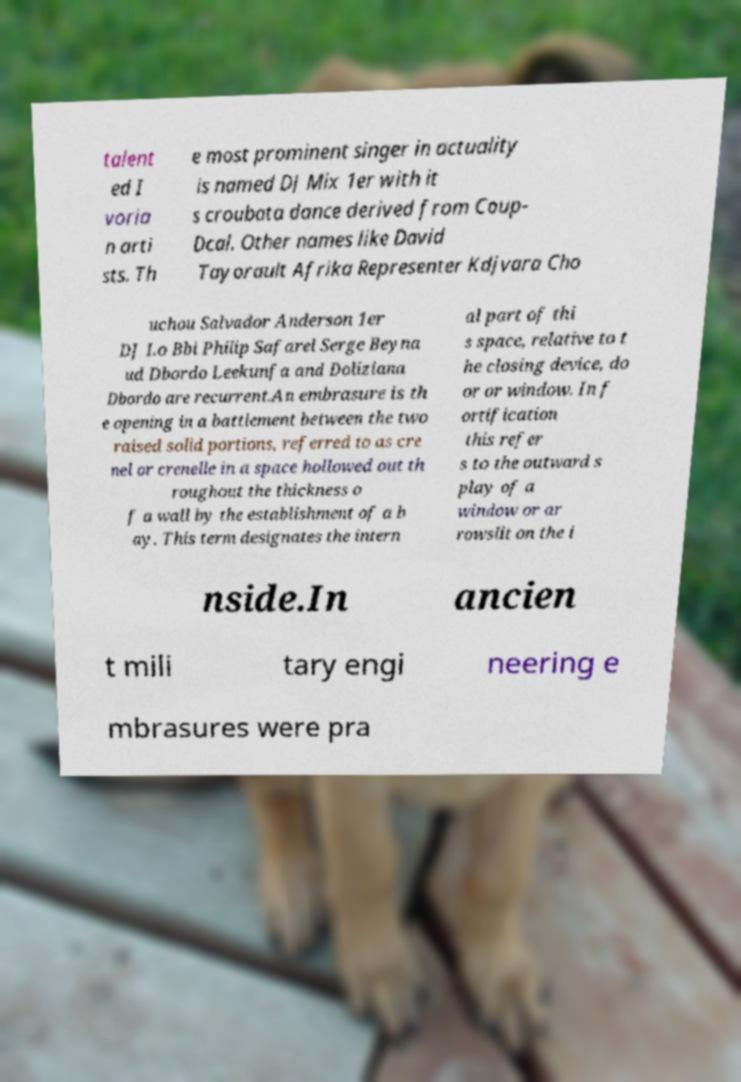Can you read and provide the text displayed in the image?This photo seems to have some interesting text. Can you extract and type it out for me? talent ed I voria n arti sts. Th e most prominent singer in actuality is named DJ Mix 1er with it s croubata dance derived from Coup- Dcal. Other names like David Tayorault Afrika Representer Kdjvara Cho uchou Salvador Anderson 1er DJ Lo Bbi Philip Safarel Serge Beyna ud Dbordo Leekunfa and Doliziana Dbordo are recurrent.An embrasure is th e opening in a battlement between the two raised solid portions, referred to as cre nel or crenelle in a space hollowed out th roughout the thickness o f a wall by the establishment of a b ay. This term designates the intern al part of thi s space, relative to t he closing device, do or or window. In f ortification this refer s to the outward s play of a window or ar rowslit on the i nside.In ancien t mili tary engi neering e mbrasures were pra 